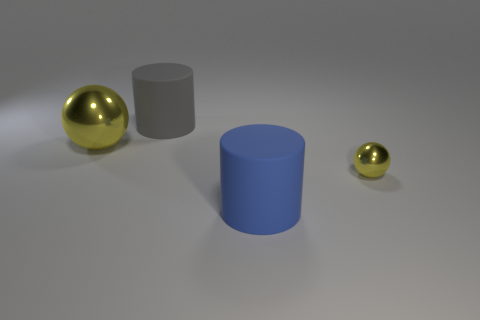Subtract all blue cylinders. How many cylinders are left? 1 Add 4 small green cylinders. How many objects exist? 8 Subtract all brown cylinders. Subtract all gray balls. How many cylinders are left? 2 Add 3 big metal spheres. How many big metal spheres exist? 4 Subtract 0 green cubes. How many objects are left? 4 Subtract 1 balls. How many balls are left? 1 Subtract all small purple spheres. Subtract all small yellow metal objects. How many objects are left? 3 Add 2 balls. How many balls are left? 4 